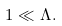Convert formula to latex. <formula><loc_0><loc_0><loc_500><loc_500>1 \ll \Lambda .</formula> 